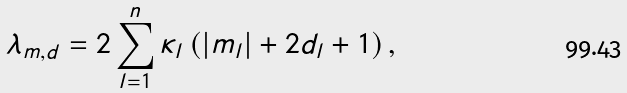<formula> <loc_0><loc_0><loc_500><loc_500>\lambda _ { m , d } = 2 \sum _ { l = 1 } ^ { n } \kappa _ { l } \left ( \left | m _ { l } \right | + 2 d _ { l } + 1 \right ) ,</formula> 